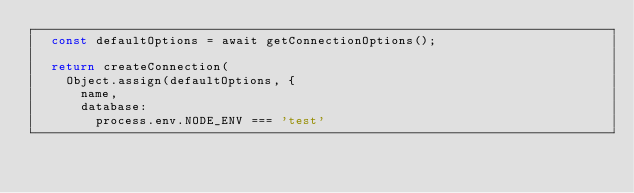<code> <loc_0><loc_0><loc_500><loc_500><_TypeScript_>  const defaultOptions = await getConnectionOptions();

  return createConnection(
    Object.assign(defaultOptions, {
      name,
      database:
        process.env.NODE_ENV === 'test'</code> 